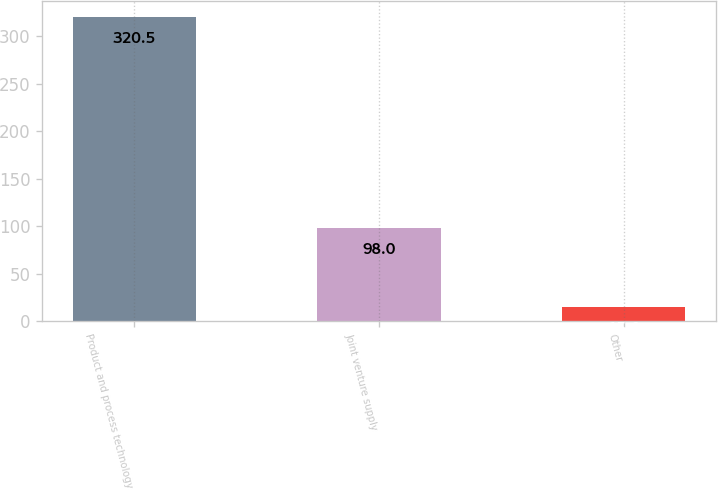Convert chart to OTSL. <chart><loc_0><loc_0><loc_500><loc_500><bar_chart><fcel>Product and process technology<fcel>Joint venture supply<fcel>Other<nl><fcel>320.5<fcel>98<fcel>15<nl></chart> 